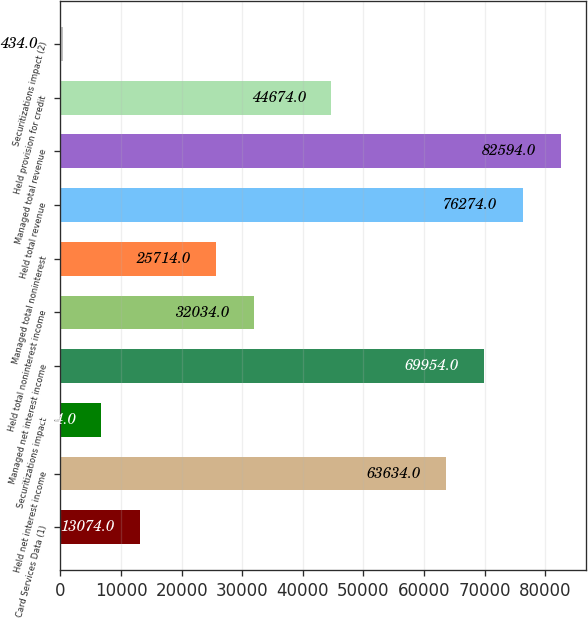Convert chart. <chart><loc_0><loc_0><loc_500><loc_500><bar_chart><fcel>Card Services Data (1)<fcel>Held net interest income<fcel>Securitizations impact<fcel>Managed net interest income<fcel>Held total noninterest income<fcel>Managed total noninterest<fcel>Held total revenue<fcel>Managed total revenue<fcel>Held provision for credit<fcel>Securitizations impact (2)<nl><fcel>13074<fcel>63634<fcel>6754<fcel>69954<fcel>32034<fcel>25714<fcel>76274<fcel>82594<fcel>44674<fcel>434<nl></chart> 